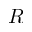<formula> <loc_0><loc_0><loc_500><loc_500>R</formula> 